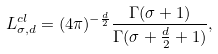Convert formula to latex. <formula><loc_0><loc_0><loc_500><loc_500>L _ { \sigma , d } ^ { c l } = ( 4 \pi ) ^ { - \frac { d } { 2 } } \frac { \Gamma ( \sigma + 1 ) } { \Gamma ( \sigma + \frac { d } { 2 } + 1 ) } ,</formula> 